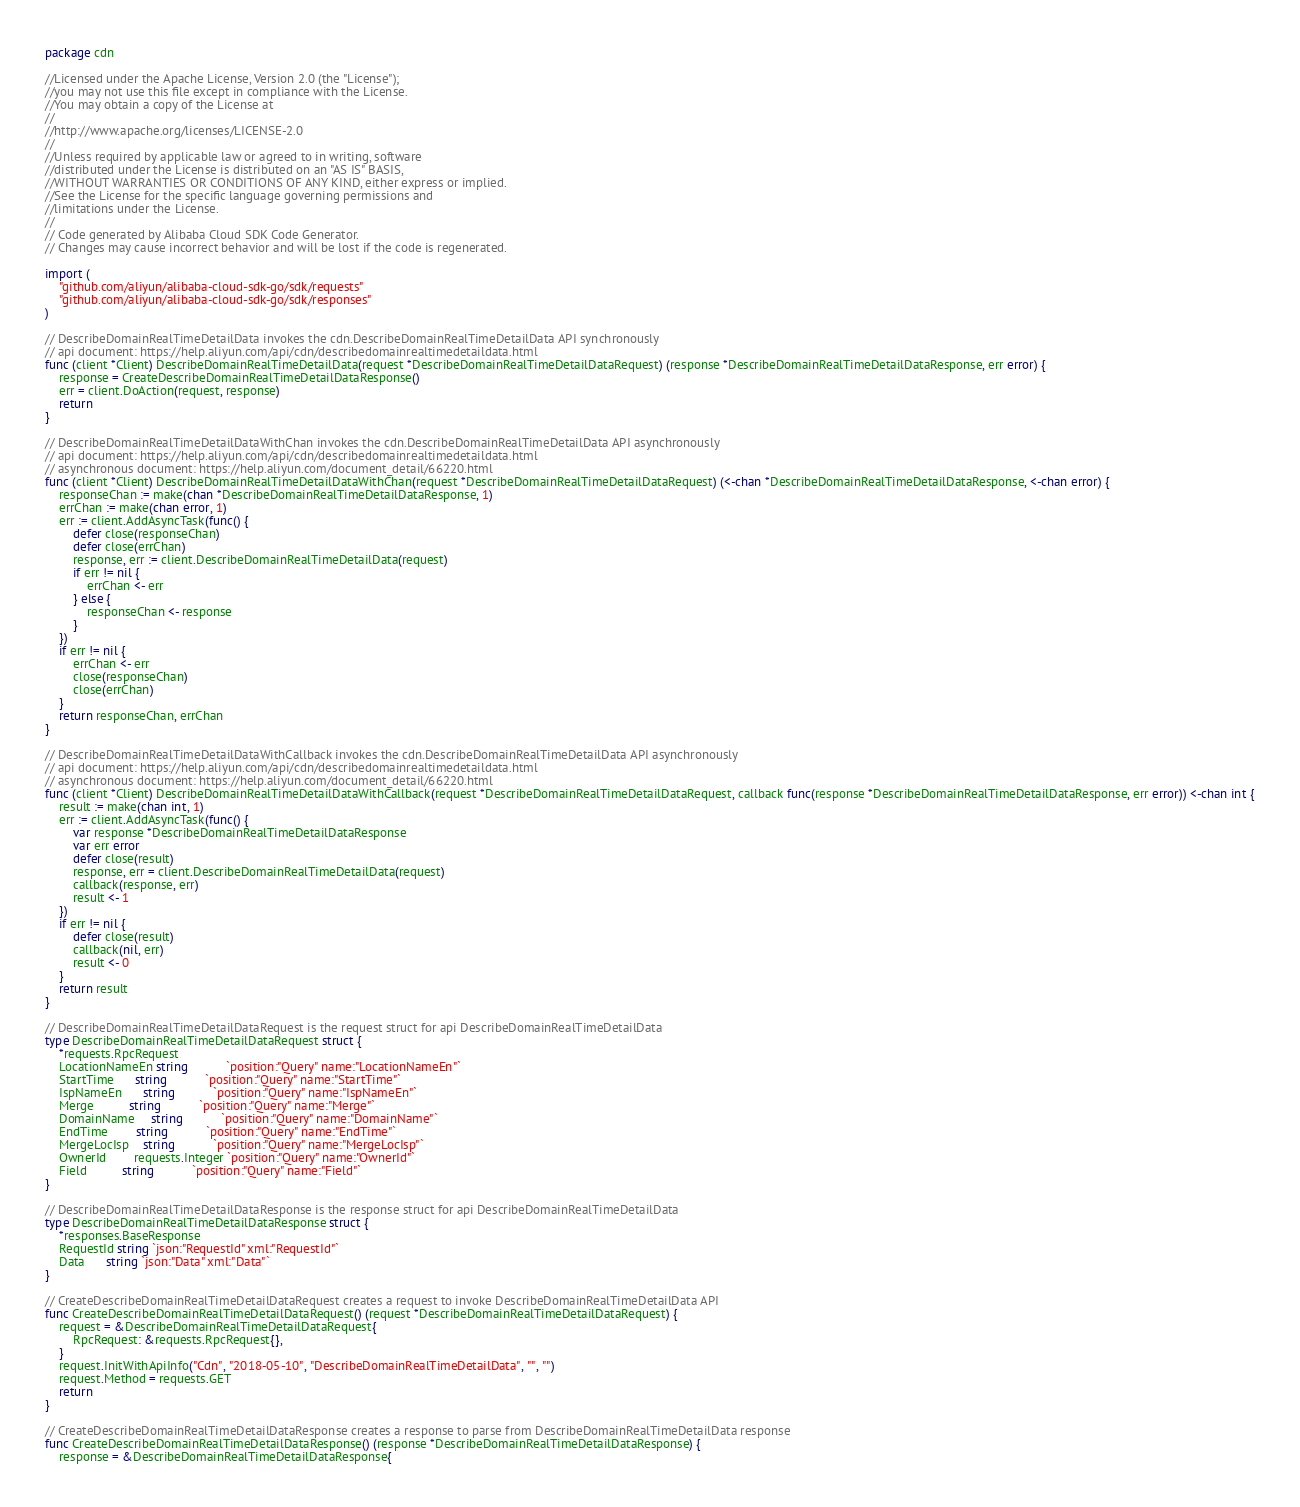Convert code to text. <code><loc_0><loc_0><loc_500><loc_500><_Go_>package cdn

//Licensed under the Apache License, Version 2.0 (the "License");
//you may not use this file except in compliance with the License.
//You may obtain a copy of the License at
//
//http://www.apache.org/licenses/LICENSE-2.0
//
//Unless required by applicable law or agreed to in writing, software
//distributed under the License is distributed on an "AS IS" BASIS,
//WITHOUT WARRANTIES OR CONDITIONS OF ANY KIND, either express or implied.
//See the License for the specific language governing permissions and
//limitations under the License.
//
// Code generated by Alibaba Cloud SDK Code Generator.
// Changes may cause incorrect behavior and will be lost if the code is regenerated.

import (
	"github.com/aliyun/alibaba-cloud-sdk-go/sdk/requests"
	"github.com/aliyun/alibaba-cloud-sdk-go/sdk/responses"
)

// DescribeDomainRealTimeDetailData invokes the cdn.DescribeDomainRealTimeDetailData API synchronously
// api document: https://help.aliyun.com/api/cdn/describedomainrealtimedetaildata.html
func (client *Client) DescribeDomainRealTimeDetailData(request *DescribeDomainRealTimeDetailDataRequest) (response *DescribeDomainRealTimeDetailDataResponse, err error) {
	response = CreateDescribeDomainRealTimeDetailDataResponse()
	err = client.DoAction(request, response)
	return
}

// DescribeDomainRealTimeDetailDataWithChan invokes the cdn.DescribeDomainRealTimeDetailData API asynchronously
// api document: https://help.aliyun.com/api/cdn/describedomainrealtimedetaildata.html
// asynchronous document: https://help.aliyun.com/document_detail/66220.html
func (client *Client) DescribeDomainRealTimeDetailDataWithChan(request *DescribeDomainRealTimeDetailDataRequest) (<-chan *DescribeDomainRealTimeDetailDataResponse, <-chan error) {
	responseChan := make(chan *DescribeDomainRealTimeDetailDataResponse, 1)
	errChan := make(chan error, 1)
	err := client.AddAsyncTask(func() {
		defer close(responseChan)
		defer close(errChan)
		response, err := client.DescribeDomainRealTimeDetailData(request)
		if err != nil {
			errChan <- err
		} else {
			responseChan <- response
		}
	})
	if err != nil {
		errChan <- err
		close(responseChan)
		close(errChan)
	}
	return responseChan, errChan
}

// DescribeDomainRealTimeDetailDataWithCallback invokes the cdn.DescribeDomainRealTimeDetailData API asynchronously
// api document: https://help.aliyun.com/api/cdn/describedomainrealtimedetaildata.html
// asynchronous document: https://help.aliyun.com/document_detail/66220.html
func (client *Client) DescribeDomainRealTimeDetailDataWithCallback(request *DescribeDomainRealTimeDetailDataRequest, callback func(response *DescribeDomainRealTimeDetailDataResponse, err error)) <-chan int {
	result := make(chan int, 1)
	err := client.AddAsyncTask(func() {
		var response *DescribeDomainRealTimeDetailDataResponse
		var err error
		defer close(result)
		response, err = client.DescribeDomainRealTimeDetailData(request)
		callback(response, err)
		result <- 1
	})
	if err != nil {
		defer close(result)
		callback(nil, err)
		result <- 0
	}
	return result
}

// DescribeDomainRealTimeDetailDataRequest is the request struct for api DescribeDomainRealTimeDetailData
type DescribeDomainRealTimeDetailDataRequest struct {
	*requests.RpcRequest
	LocationNameEn string           `position:"Query" name:"LocationNameEn"`
	StartTime      string           `position:"Query" name:"StartTime"`
	IspNameEn      string           `position:"Query" name:"IspNameEn"`
	Merge          string           `position:"Query" name:"Merge"`
	DomainName     string           `position:"Query" name:"DomainName"`
	EndTime        string           `position:"Query" name:"EndTime"`
	MergeLocIsp    string           `position:"Query" name:"MergeLocIsp"`
	OwnerId        requests.Integer `position:"Query" name:"OwnerId"`
	Field          string           `position:"Query" name:"Field"`
}

// DescribeDomainRealTimeDetailDataResponse is the response struct for api DescribeDomainRealTimeDetailData
type DescribeDomainRealTimeDetailDataResponse struct {
	*responses.BaseResponse
	RequestId string `json:"RequestId" xml:"RequestId"`
	Data      string `json:"Data" xml:"Data"`
}

// CreateDescribeDomainRealTimeDetailDataRequest creates a request to invoke DescribeDomainRealTimeDetailData API
func CreateDescribeDomainRealTimeDetailDataRequest() (request *DescribeDomainRealTimeDetailDataRequest) {
	request = &DescribeDomainRealTimeDetailDataRequest{
		RpcRequest: &requests.RpcRequest{},
	}
	request.InitWithApiInfo("Cdn", "2018-05-10", "DescribeDomainRealTimeDetailData", "", "")
	request.Method = requests.GET
	return
}

// CreateDescribeDomainRealTimeDetailDataResponse creates a response to parse from DescribeDomainRealTimeDetailData response
func CreateDescribeDomainRealTimeDetailDataResponse() (response *DescribeDomainRealTimeDetailDataResponse) {
	response = &DescribeDomainRealTimeDetailDataResponse{</code> 